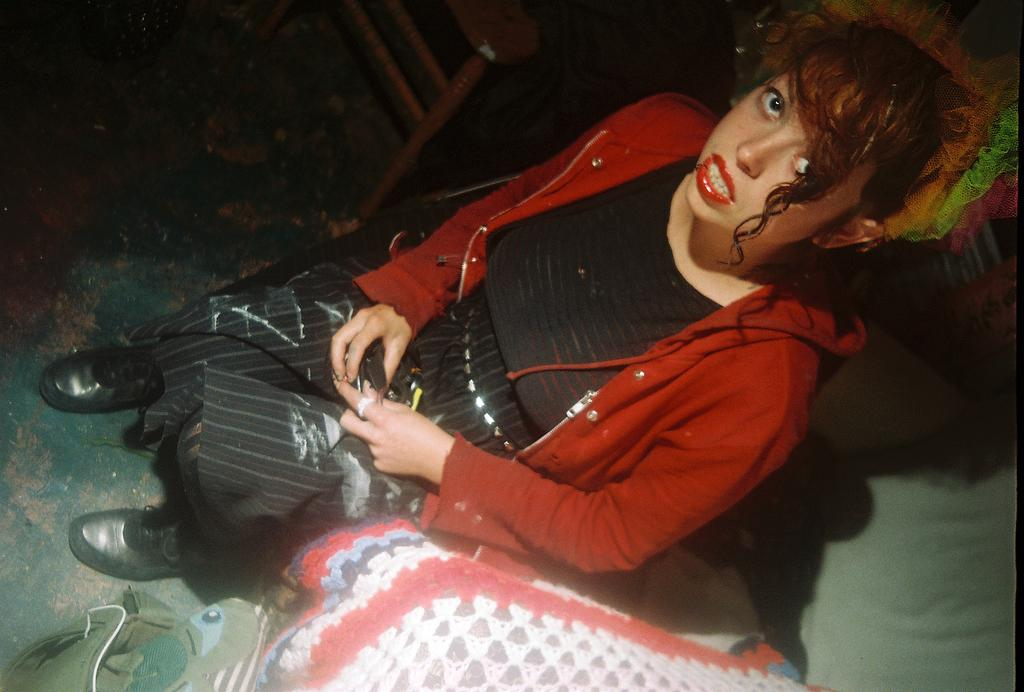What is the woman doing in the image? The woman is sitting in the image. What object is present in the image that might be used for placing items? There is a table in the image. What type of scarf is the cat wearing in the image? There is no cat or scarf present in the image. How many flies can be seen buzzing around the woman in the image? There are no flies present in the image. 